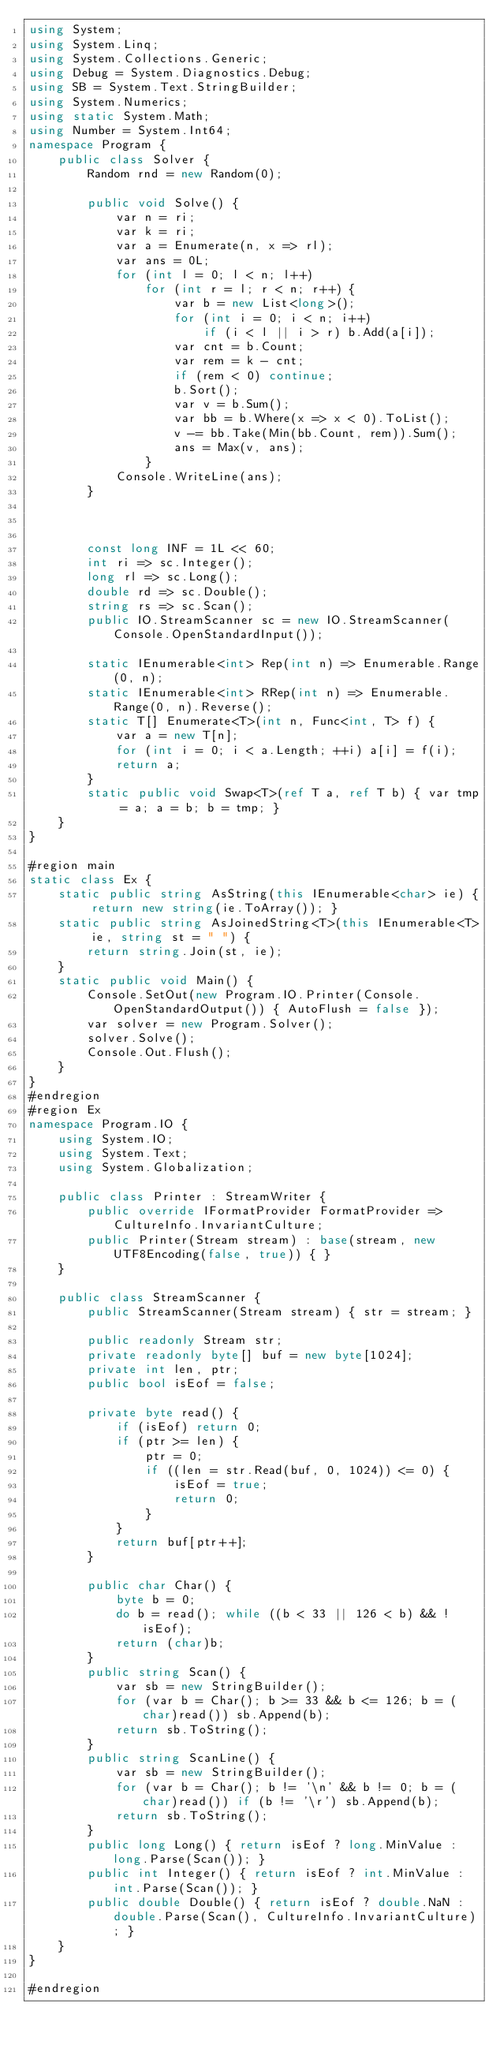Convert code to text. <code><loc_0><loc_0><loc_500><loc_500><_C#_>using System;
using System.Linq;
using System.Collections.Generic;
using Debug = System.Diagnostics.Debug;
using SB = System.Text.StringBuilder;
using System.Numerics;
using static System.Math;
using Number = System.Int64;
namespace Program {
    public class Solver {
        Random rnd = new Random(0);

        public void Solve() {
            var n = ri;
            var k = ri;
            var a = Enumerate(n, x => rl);
            var ans = 0L;
            for (int l = 0; l < n; l++)
                for (int r = l; r < n; r++) {
                    var b = new List<long>();
                    for (int i = 0; i < n; i++)
                        if (i < l || i > r) b.Add(a[i]);
                    var cnt = b.Count;
                    var rem = k - cnt;
                    if (rem < 0) continue;
                    b.Sort();
                    var v = b.Sum();
                    var bb = b.Where(x => x < 0).ToList();
                    v -= bb.Take(Min(bb.Count, rem)).Sum();
                    ans = Max(v, ans);
                }
            Console.WriteLine(ans);
        }



        const long INF = 1L << 60;
        int ri => sc.Integer();
        long rl => sc.Long();
        double rd => sc.Double();
        string rs => sc.Scan();
        public IO.StreamScanner sc = new IO.StreamScanner(Console.OpenStandardInput());

        static IEnumerable<int> Rep(int n) => Enumerable.Range(0, n);
        static IEnumerable<int> RRep(int n) => Enumerable.Range(0, n).Reverse();
        static T[] Enumerate<T>(int n, Func<int, T> f) {
            var a = new T[n];
            for (int i = 0; i < a.Length; ++i) a[i] = f(i);
            return a;
        }
        static public void Swap<T>(ref T a, ref T b) { var tmp = a; a = b; b = tmp; }
    }
}

#region main
static class Ex {
    static public string AsString(this IEnumerable<char> ie) { return new string(ie.ToArray()); }
    static public string AsJoinedString<T>(this IEnumerable<T> ie, string st = " ") {
        return string.Join(st, ie);
    }
    static public void Main() {
        Console.SetOut(new Program.IO.Printer(Console.OpenStandardOutput()) { AutoFlush = false });
        var solver = new Program.Solver();
        solver.Solve();
        Console.Out.Flush();
    }
}
#endregion
#region Ex
namespace Program.IO {
    using System.IO;
    using System.Text;
    using System.Globalization;

    public class Printer : StreamWriter {
        public override IFormatProvider FormatProvider => CultureInfo.InvariantCulture;
        public Printer(Stream stream) : base(stream, new UTF8Encoding(false, true)) { }
    }

    public class StreamScanner {
        public StreamScanner(Stream stream) { str = stream; }

        public readonly Stream str;
        private readonly byte[] buf = new byte[1024];
        private int len, ptr;
        public bool isEof = false;

        private byte read() {
            if (isEof) return 0;
            if (ptr >= len) {
                ptr = 0;
                if ((len = str.Read(buf, 0, 1024)) <= 0) {
                    isEof = true;
                    return 0;
                }
            }
            return buf[ptr++];
        }

        public char Char() {
            byte b = 0;
            do b = read(); while ((b < 33 || 126 < b) && !isEof);
            return (char)b;
        }
        public string Scan() {
            var sb = new StringBuilder();
            for (var b = Char(); b >= 33 && b <= 126; b = (char)read()) sb.Append(b);
            return sb.ToString();
        }
        public string ScanLine() {
            var sb = new StringBuilder();
            for (var b = Char(); b != '\n' && b != 0; b = (char)read()) if (b != '\r') sb.Append(b);
            return sb.ToString();
        }
        public long Long() { return isEof ? long.MinValue : long.Parse(Scan()); }
        public int Integer() { return isEof ? int.MinValue : int.Parse(Scan()); }
        public double Double() { return isEof ? double.NaN : double.Parse(Scan(), CultureInfo.InvariantCulture); }
    }
}

#endregion

</code> 